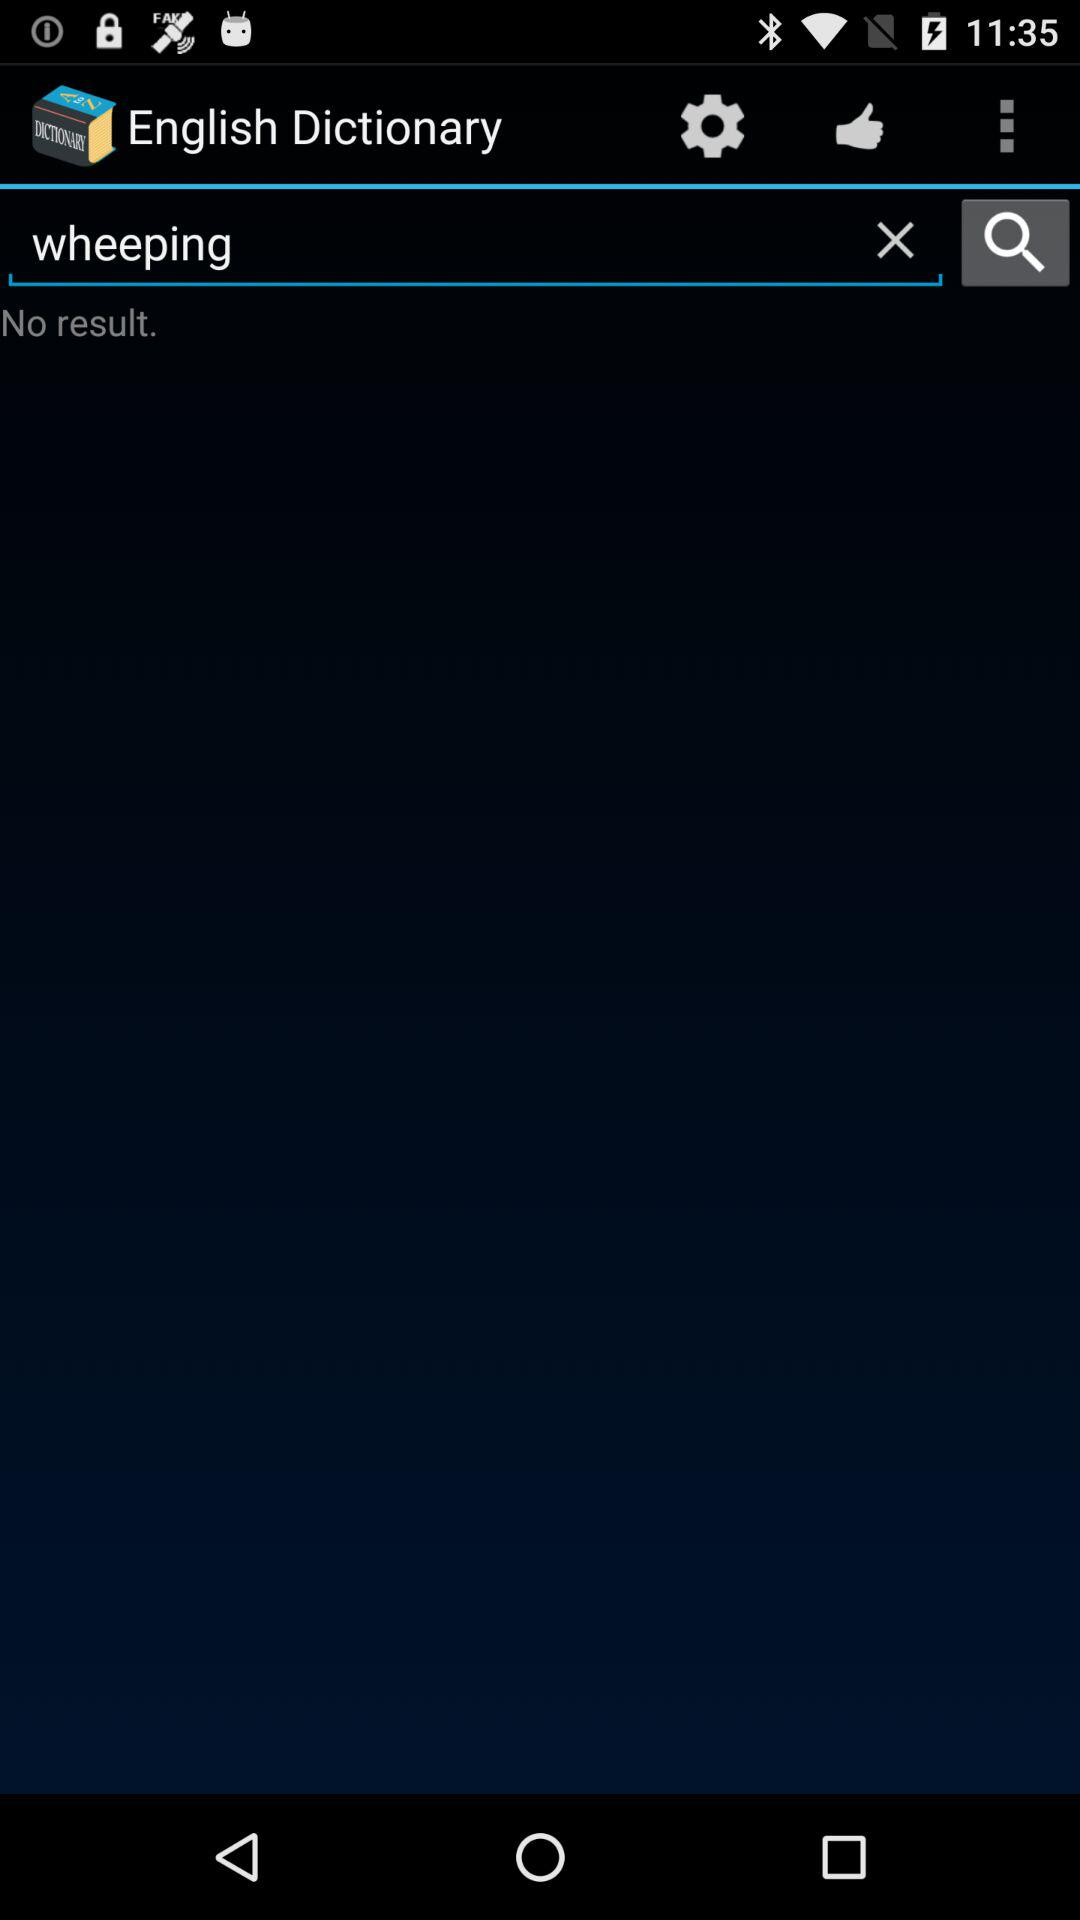What text is entered in the input field? The entered text is wheeping. 